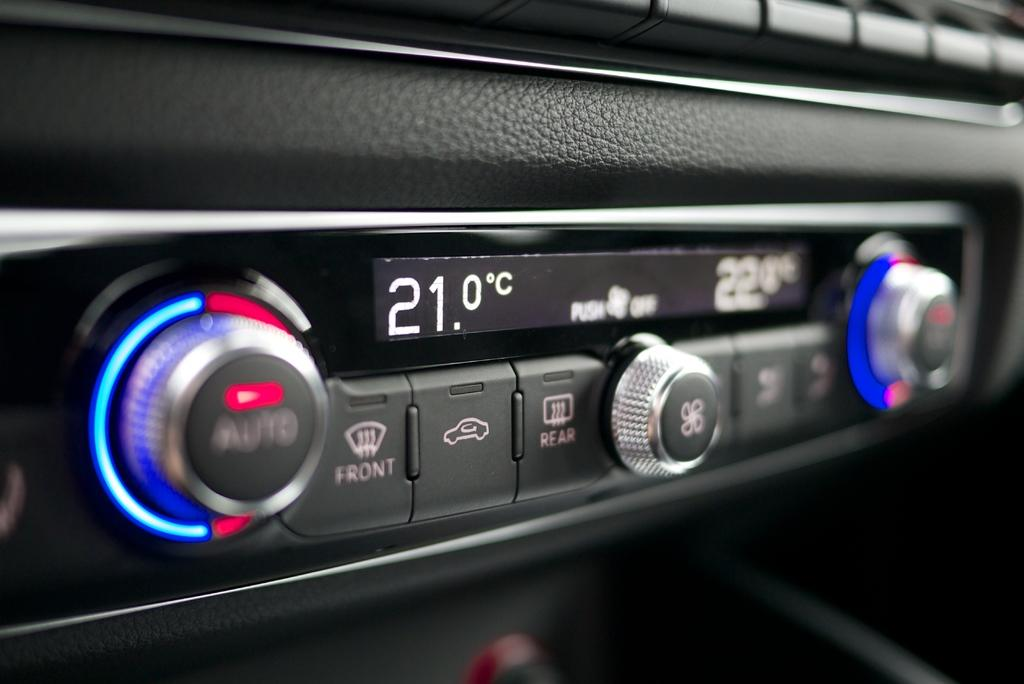What type of objects can be seen in the image? There are buttons, regulators, and lights in the image. What else is present in the image besides these objects? There is text in the middle of the image. What type of plants can be seen growing near the buttons in the image? There are no plants present in the image; it only features buttons, regulators, lights, and text. Are there any boats visible in the image? There are no boats present in the image. 